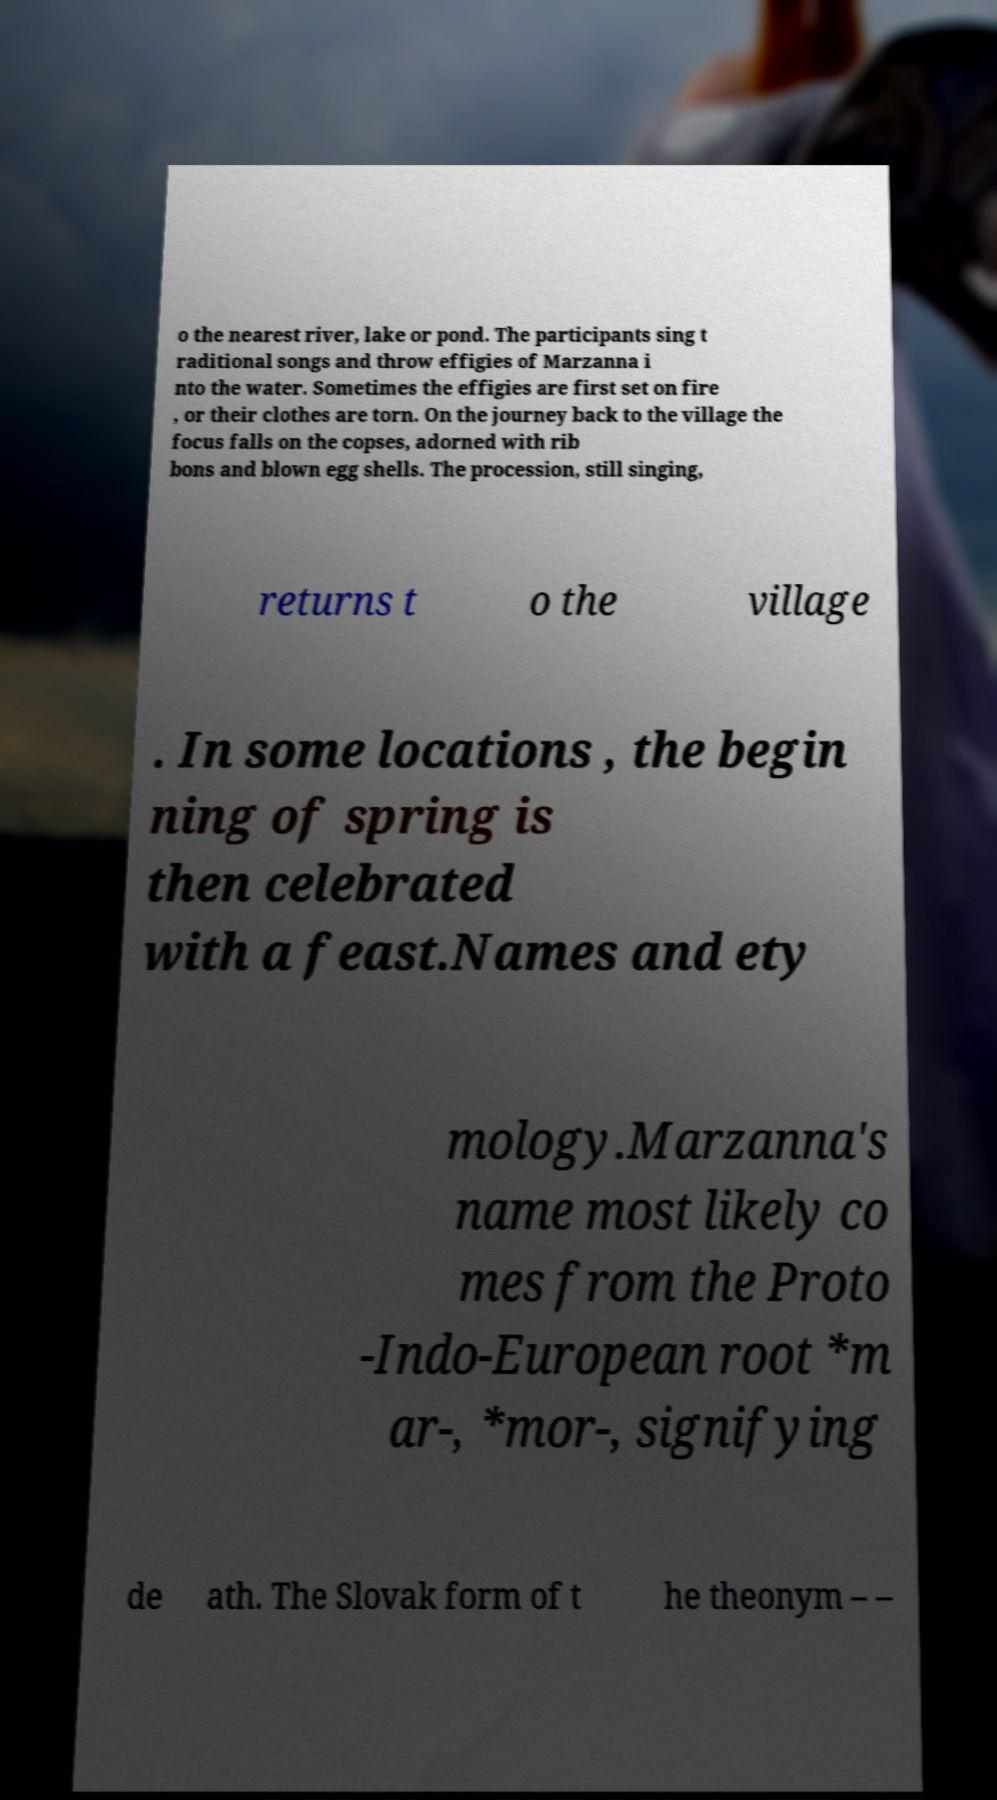Could you extract and type out the text from this image? o the nearest river, lake or pond. The participants sing t raditional songs and throw effigies of Marzanna i nto the water. Sometimes the effigies are first set on fire , or their clothes are torn. On the journey back to the village the focus falls on the copses, adorned with rib bons and blown egg shells. The procession, still singing, returns t o the village . In some locations , the begin ning of spring is then celebrated with a feast.Names and ety mology.Marzanna's name most likely co mes from the Proto -Indo-European root *m ar-, *mor-, signifying de ath. The Slovak form of t he theonym – – 